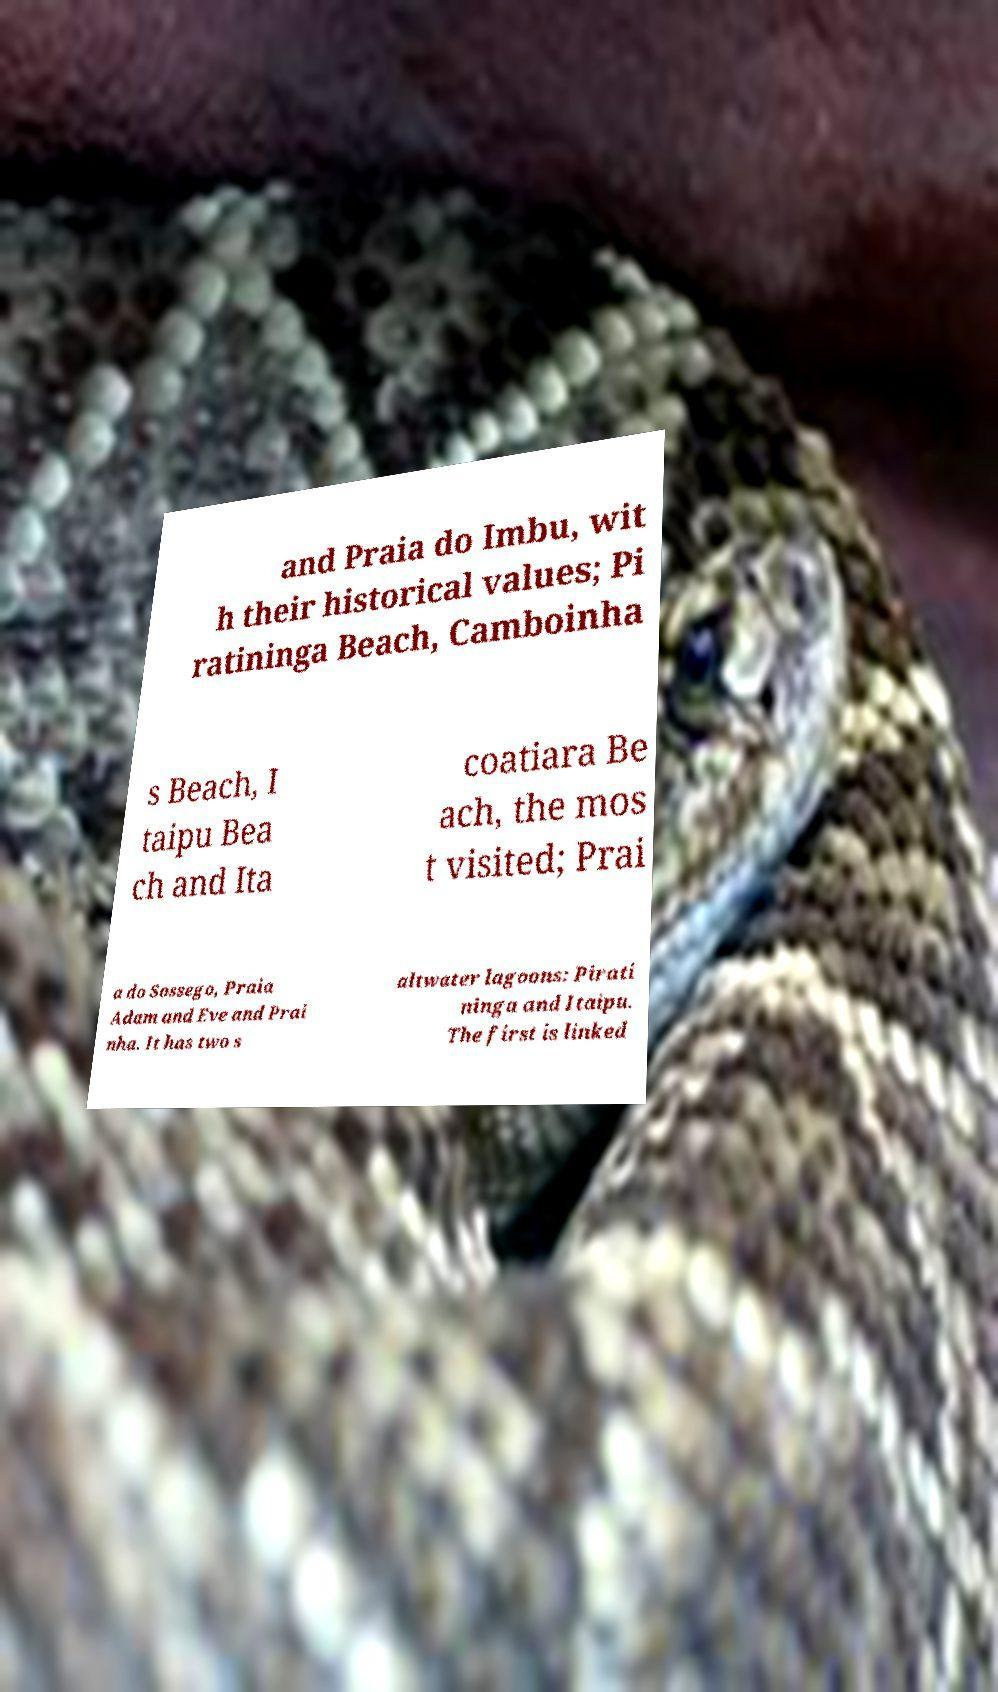Please identify and transcribe the text found in this image. and Praia do Imbu, wit h their historical values; Pi ratininga Beach, Camboinha s Beach, I taipu Bea ch and Ita coatiara Be ach, the mos t visited; Prai a do Sossego, Praia Adam and Eve and Prai nha. It has two s altwater lagoons: Pirati ninga and Itaipu. The first is linked 